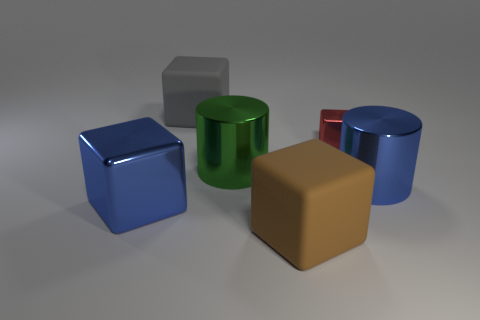Subtract all gray rubber blocks. How many blocks are left? 3 Subtract all gray blocks. How many blocks are left? 3 Add 1 brown rubber things. How many objects exist? 7 Subtract all cylinders. How many objects are left? 4 Subtract 0 purple blocks. How many objects are left? 6 Subtract all cyan blocks. Subtract all purple cylinders. How many blocks are left? 4 Subtract all blue objects. Subtract all large green cylinders. How many objects are left? 3 Add 3 big things. How many big things are left? 8 Add 6 small purple shiny balls. How many small purple shiny balls exist? 6 